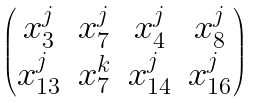<formula> <loc_0><loc_0><loc_500><loc_500>\begin{pmatrix} x _ { 3 } ^ { j } & x _ { 7 } ^ { j } & x _ { 4 } ^ { j } & x _ { 8 } ^ { j } \\ x _ { 1 3 } ^ { j } & x _ { 7 } ^ { k } & x _ { 1 4 } ^ { j } & x _ { 1 6 } ^ { j } \end{pmatrix}</formula> 